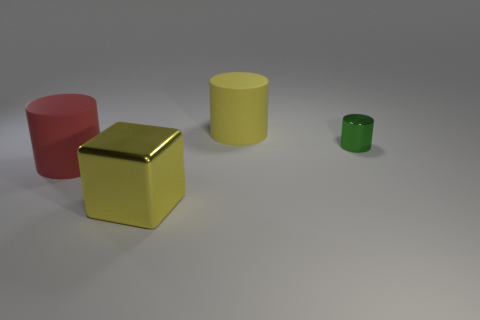Subtract all tiny green metallic cylinders. How many cylinders are left? 2 Subtract all yellow cylinders. How many cylinders are left? 2 Add 1 blue metallic cubes. How many objects exist? 5 Subtract all gray blocks. How many cyan cylinders are left? 0 Subtract all cyan rubber blocks. Subtract all cylinders. How many objects are left? 1 Add 3 big red rubber cylinders. How many big red rubber cylinders are left? 4 Add 4 tiny yellow objects. How many tiny yellow objects exist? 4 Subtract 0 red spheres. How many objects are left? 4 Subtract all cubes. How many objects are left? 3 Subtract 3 cylinders. How many cylinders are left? 0 